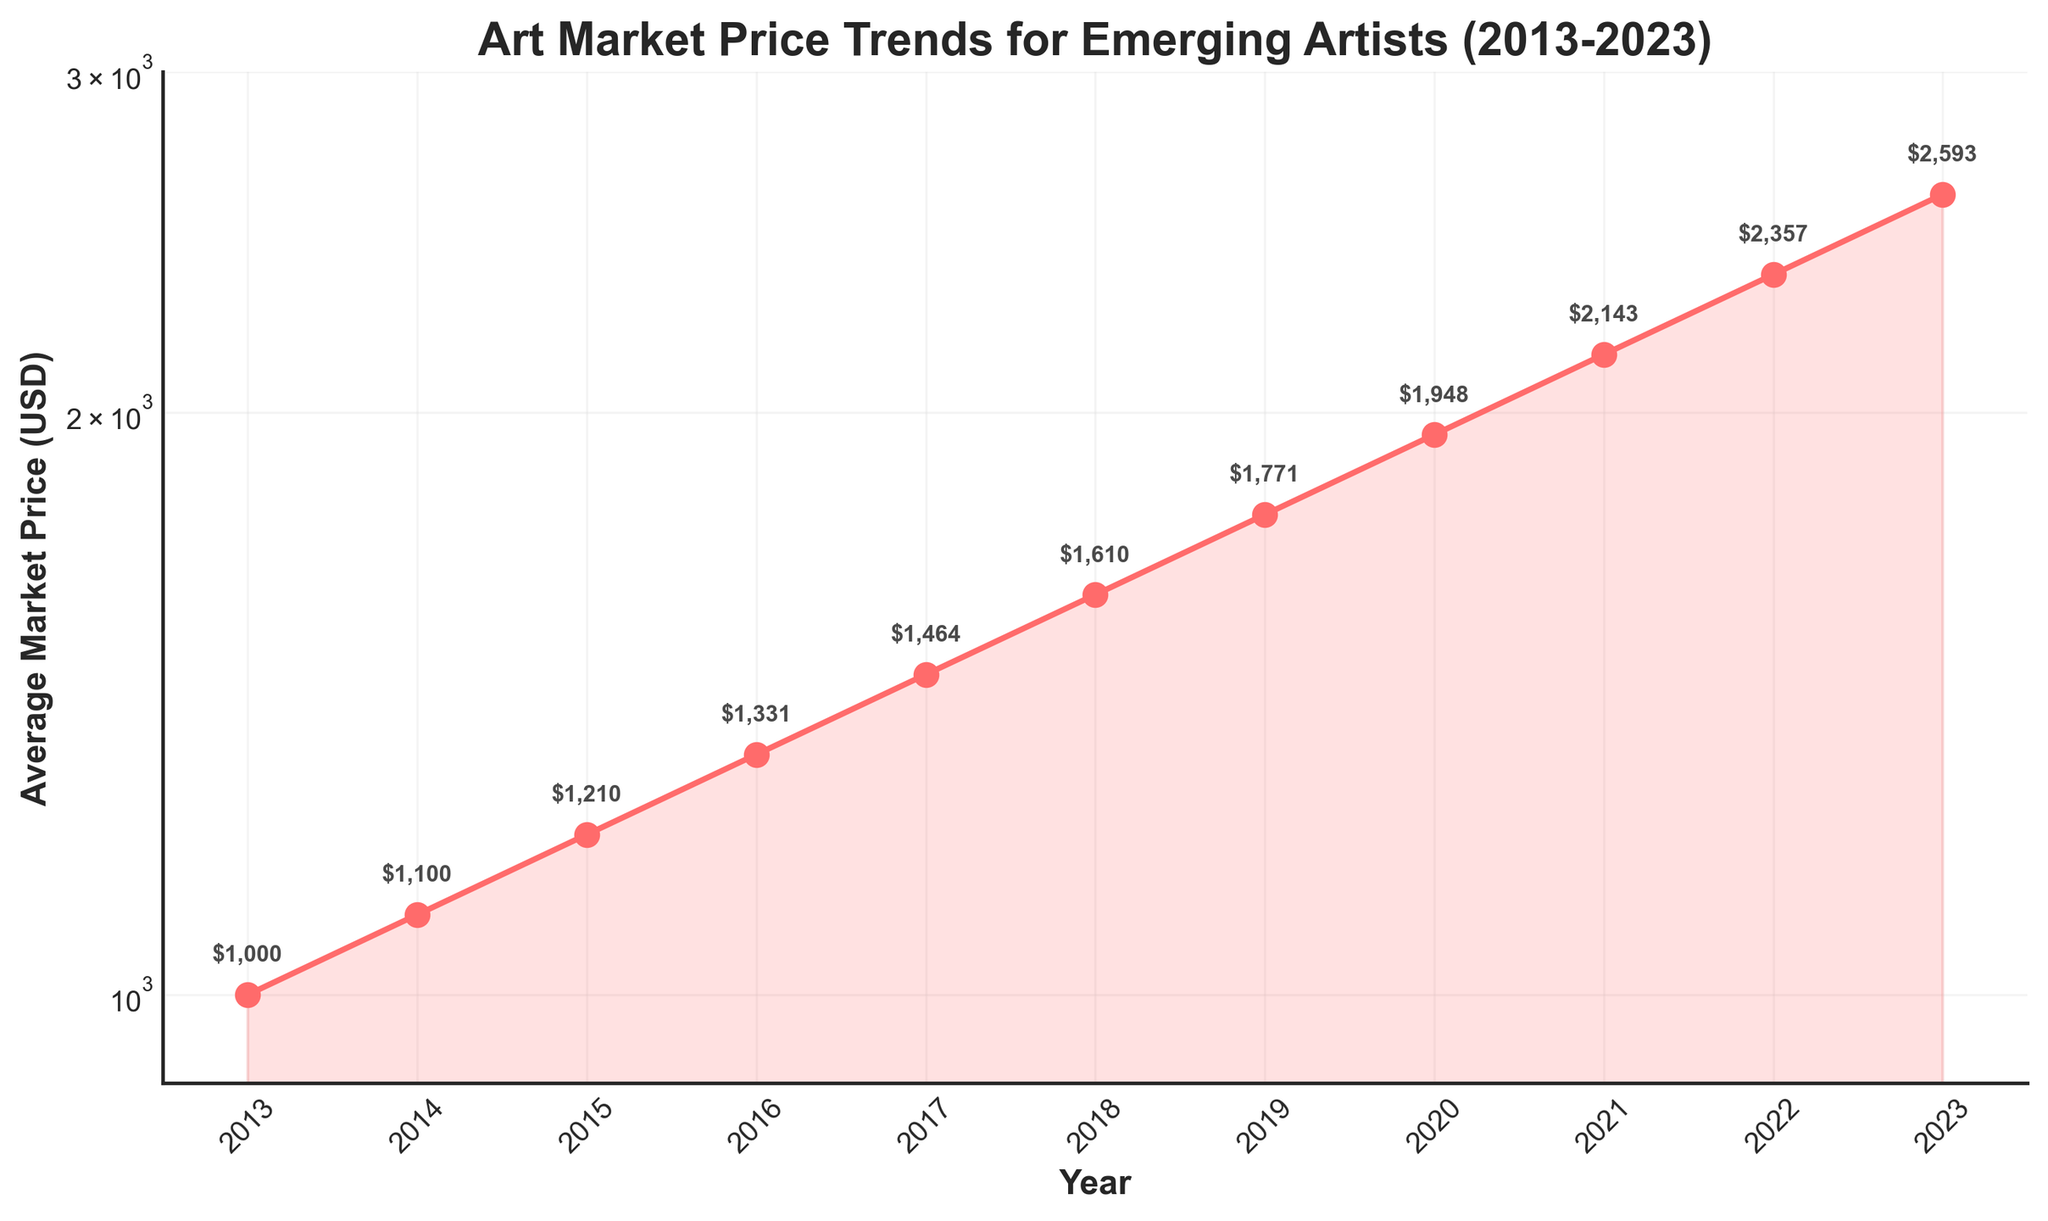What is the title of the figure? The title of the figure is given at the top of the plot. It reads: "Art Market Price Trends for Emerging Artists (2013-2023)".
Answer: Art Market Price Trends for Emerging Artists (2013-2023) How many years are shown in the figure? Each year is marked along the x-axis, starting from 2013 and ending in 2023. Counting the years results in a total of 11 years.
Answer: 11 years Describe the trend of the average market price for emerging artists from 2013 to 2023. Observing the y-axis which is on a logarithmic scale and the upward movement of the plotted line, the average market price shows a consistent increasing trend from 2013 to 2023.
Answer: Increasing trend What is the log scale? The y-axis uses a logarithmic scale, meaning each tick increase represents a tenfold increase in the value. This helps in better visualization of large-scale changes.
Answer: Logarithmic scale What was the average market price for emerging artists in 2017? Looking at the point on the plotted line for the year 2017, the price reads 1464 USD.
Answer: 1464 USD Between which two consecutive years was the greatest increase in average market price observed? Comparing the differences between consecutive years, the highest increase is observed between 2022 and 2023 (2593 - 2357 = 236 USD).
Answer: 2022 and 2023 What is the percentage increase in the market price from 2013 to 2023? Initial value in 2013 is 1000 USD, and final value in 2023 is 2593 USD. The percentage increase is ((2593 - 1000) / 1000) * 100 ≈ 159.3%.
Answer: 159.3% How does the price trend reflect the market conditions over the decade? The steadily increasing trend suggests that the demand and market value for emerging artists have been consistently growing over the last decade, reflecting possibly improving market conditions or increased interest in emerging artists.
Answer: Consistently growing Which year had the closest average market price to 2000 USD? Observing the plotted points, the year 2020 had an average market price of 1948 USD, very close to 2000 USD.
Answer: 2020 Why is a logarithmic scale used in this plot? Logarithmic scales are useful for large ranges of values, as they can clearly show both small and large changes, particularly useful in financial and market trend data where changes can span several orders of magnitude.
Answer: To clearly show large and small changes 